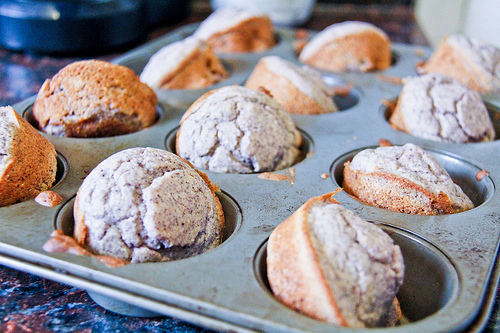<image>
Can you confirm if the muffin is in the tin? Yes. The muffin is contained within or inside the tin, showing a containment relationship. 